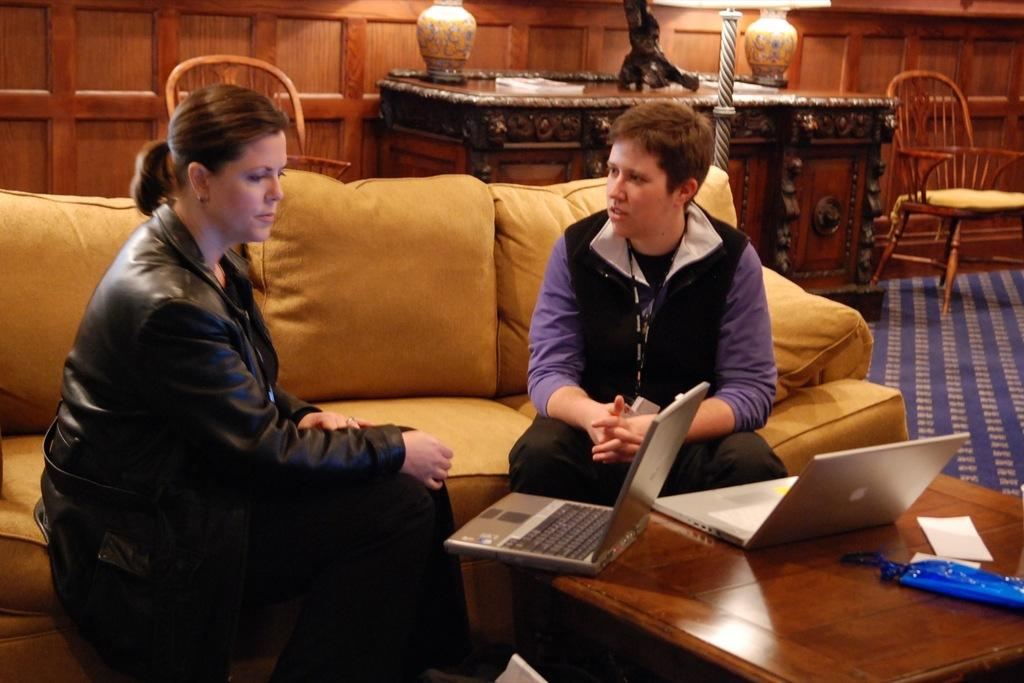How many people are sitting on the sofa in the image? There are two people sitting on the sofa in the image. What objects are on the table in front of the sofa? There are laptops on a table in front of the sofa. What can be seen in the background of the image? There are chairs and a wall visible in the background of the image. What type of skin is visible on the quarter in the image? There is no quarter or skin present in the image. What request is being made by the people sitting on the sofa in the image? The image does not provide any information about a request being made by the people sitting on the sofa. 